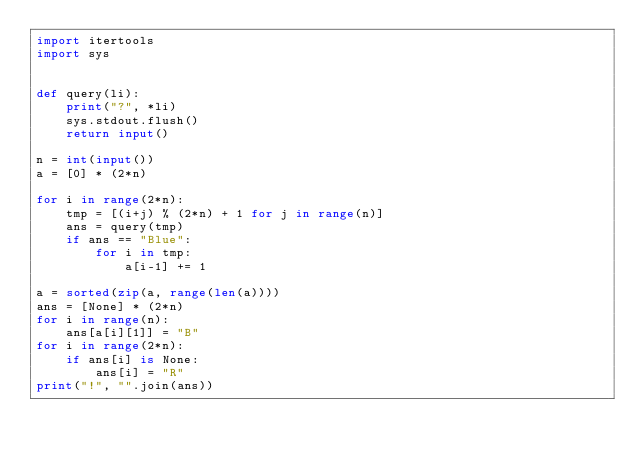<code> <loc_0><loc_0><loc_500><loc_500><_Python_>import itertools
import sys


def query(li):
    print("?", *li)
    sys.stdout.flush()
    return input()

n = int(input())
a = [0] * (2*n)

for i in range(2*n):
    tmp = [(i+j) % (2*n) + 1 for j in range(n)]
    ans = query(tmp)
    if ans == "Blue":
        for i in tmp:
            a[i-1] += 1

a = sorted(zip(a, range(len(a))))
ans = [None] * (2*n)
for i in range(n):
    ans[a[i][1]] = "B"
for i in range(2*n):
    if ans[i] is None:
        ans[i] = "R"
print("!", "".join(ans))</code> 